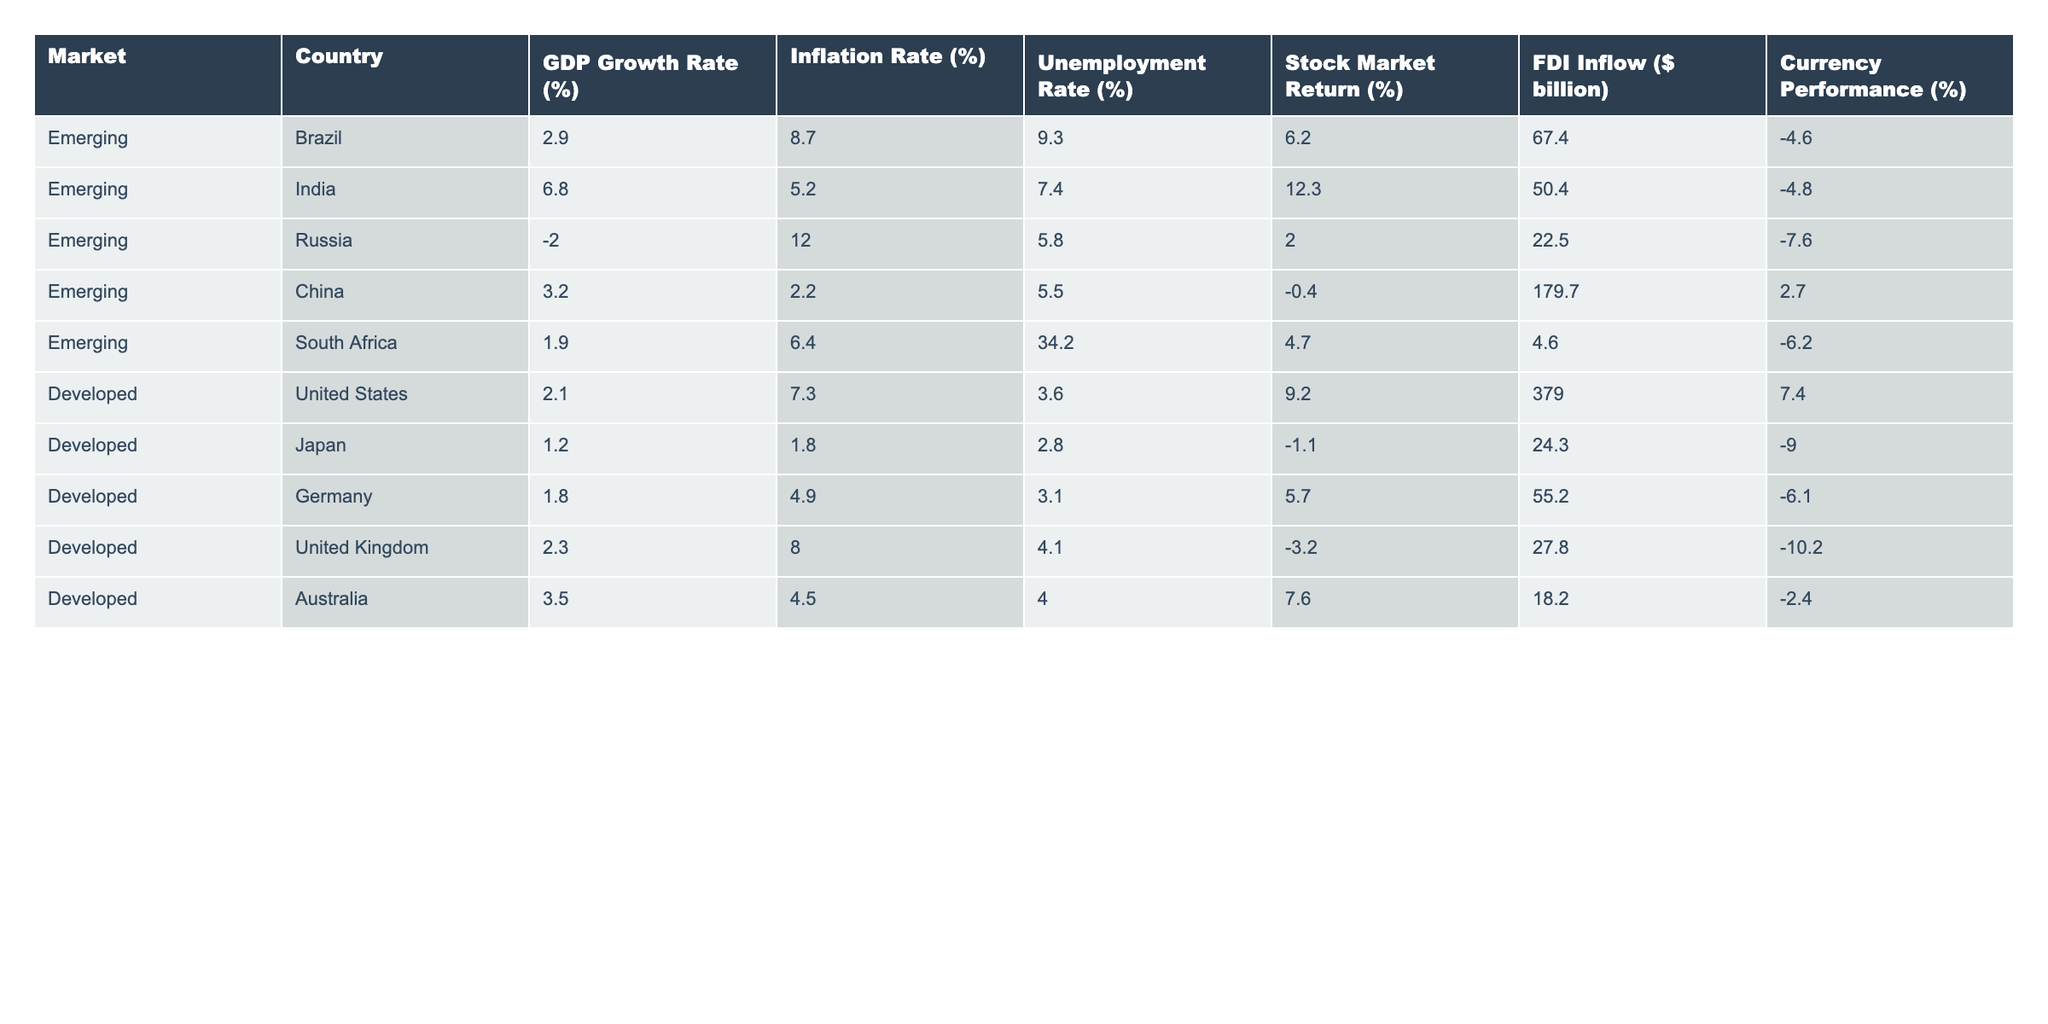What's the GDP growth rate for India? The GDP growth rate for India is explicitly listed in the table under the column for GDP Growth Rate (%). It shows a value of 6.8%.
Answer: 6.8% Which emerging market has the highest foreign direct investment (FDI) inflow? In the table, the FDI Inflow ($ billion) for China is 179.7 billion, which is the highest among the emerging markets listed.
Answer: China What is the average inflation rate for developed markets? The inflation rates for developed markets are as follows: United States (7.3%), Japan (1.8%), Germany (4.9%), United Kingdom (8.0%), and Australia (4.5%). The average is calculated as (7.3 + 1.8 + 4.9 + 8.0 + 4.5) / 5 = 5.13%.
Answer: 5.13% Is it true that Brazil has a higher unemployment rate than the United States? The unemployment rate for Brazil is 9.3%, while for the United States, it is 3.6%. Since 9.3% is greater than 3.6%, the statement is true.
Answer: Yes What is the difference in stock market return between India and the United Kingdom? The stock market return for India is 12.3%, and for the United Kingdom, it is -3.2%. The difference is calculated as 12.3 - (-3.2) = 15.5%.
Answer: 15.5% 